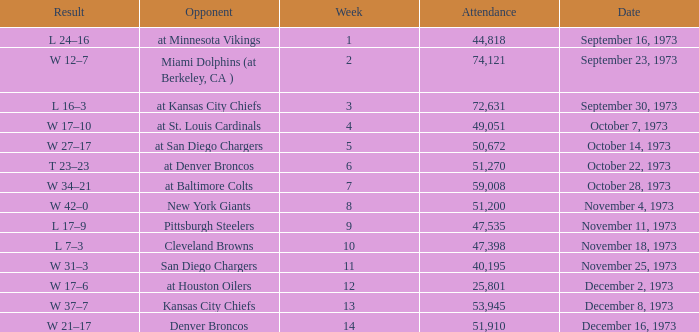What is the highest number in attendance against the game at Kansas City Chiefs? 72631.0. 